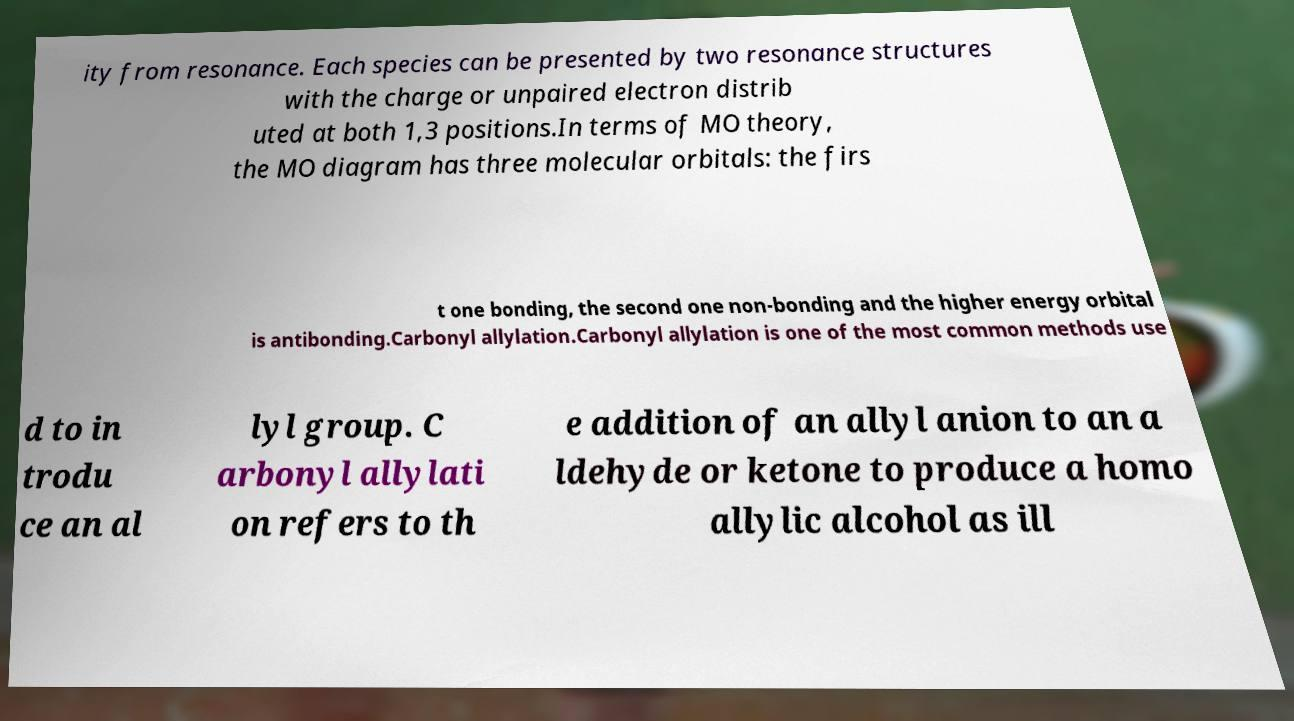Please identify and transcribe the text found in this image. ity from resonance. Each species can be presented by two resonance structures with the charge or unpaired electron distrib uted at both 1,3 positions.In terms of MO theory, the MO diagram has three molecular orbitals: the firs t one bonding, the second one non-bonding and the higher energy orbital is antibonding.Carbonyl allylation.Carbonyl allylation is one of the most common methods use d to in trodu ce an al lyl group. C arbonyl allylati on refers to th e addition of an allyl anion to an a ldehyde or ketone to produce a homo allylic alcohol as ill 